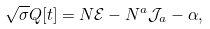<formula> <loc_0><loc_0><loc_500><loc_500>\sqrt { \sigma } Q [ t ] = N \mathcal { E } - N ^ { a } \mathcal { J } _ { a } - \alpha ,</formula> 